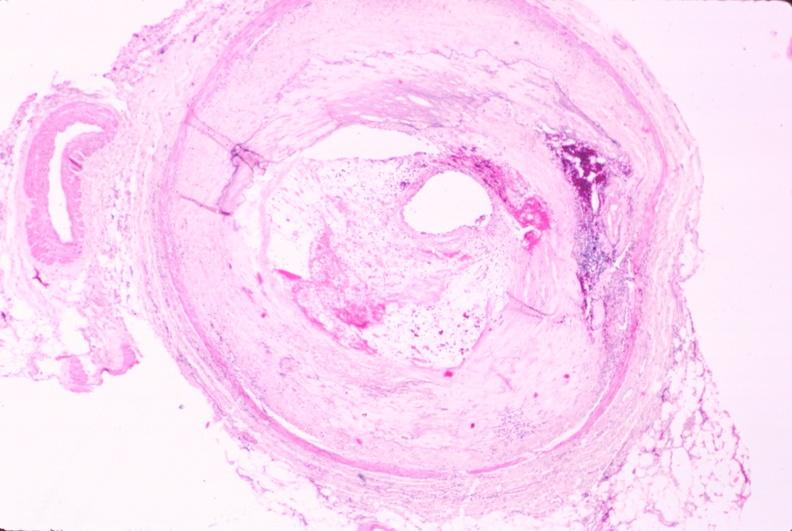s aorta present?
Answer the question using a single word or phrase. No 